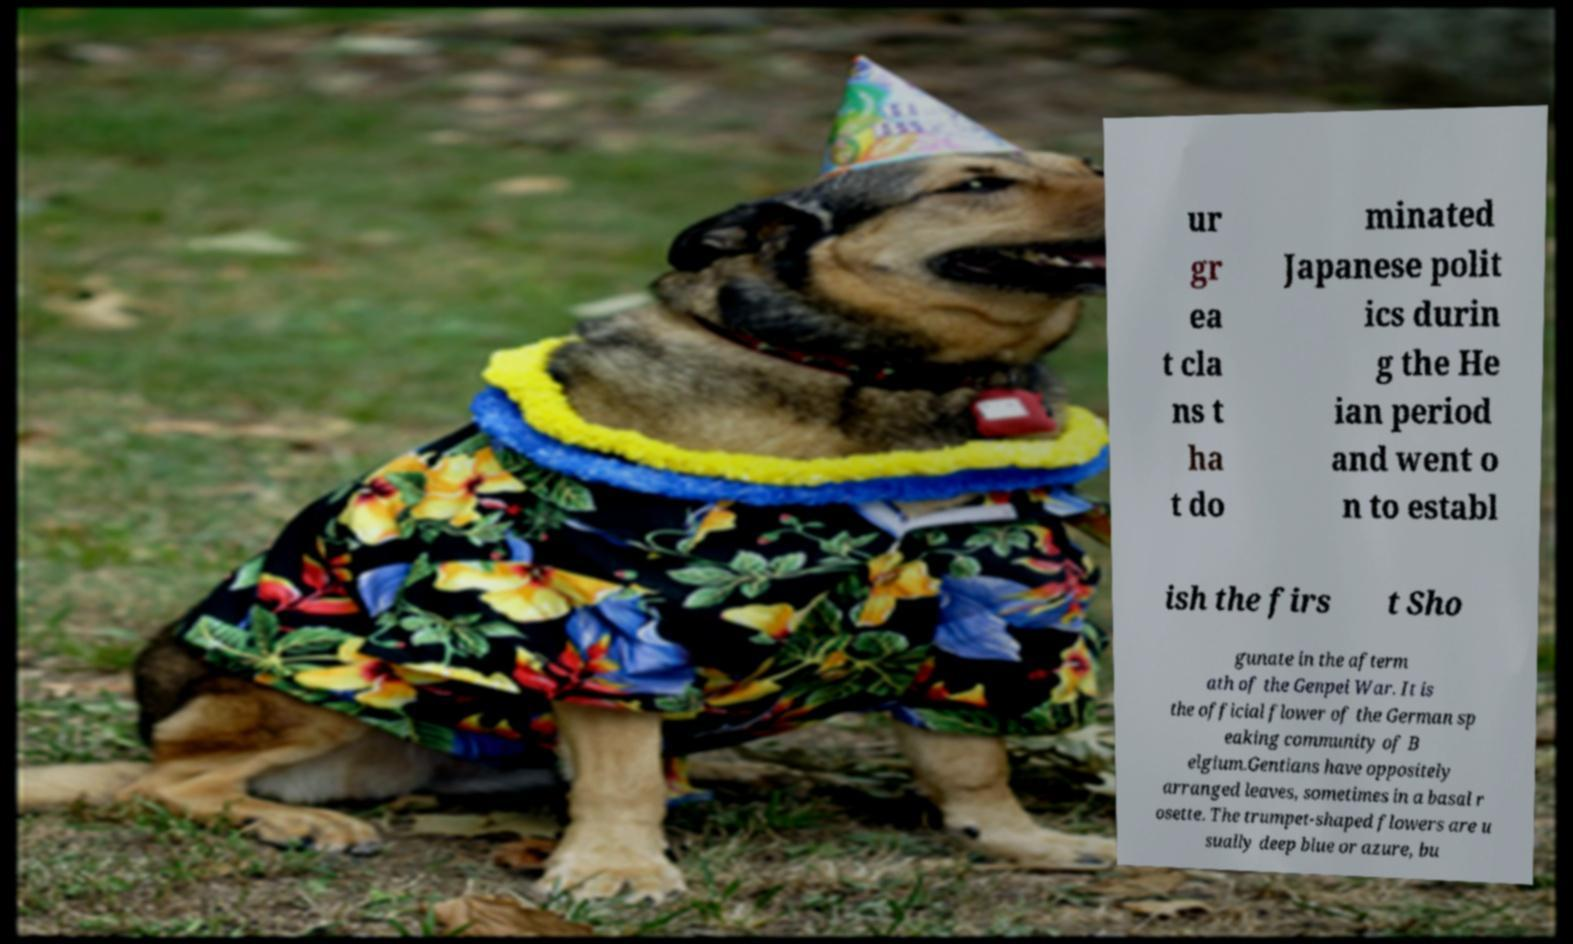Can you accurately transcribe the text from the provided image for me? ur gr ea t cla ns t ha t do minated Japanese polit ics durin g the He ian period and went o n to establ ish the firs t Sho gunate in the afterm ath of the Genpei War. It is the official flower of the German sp eaking community of B elgium.Gentians have oppositely arranged leaves, sometimes in a basal r osette. The trumpet-shaped flowers are u sually deep blue or azure, bu 